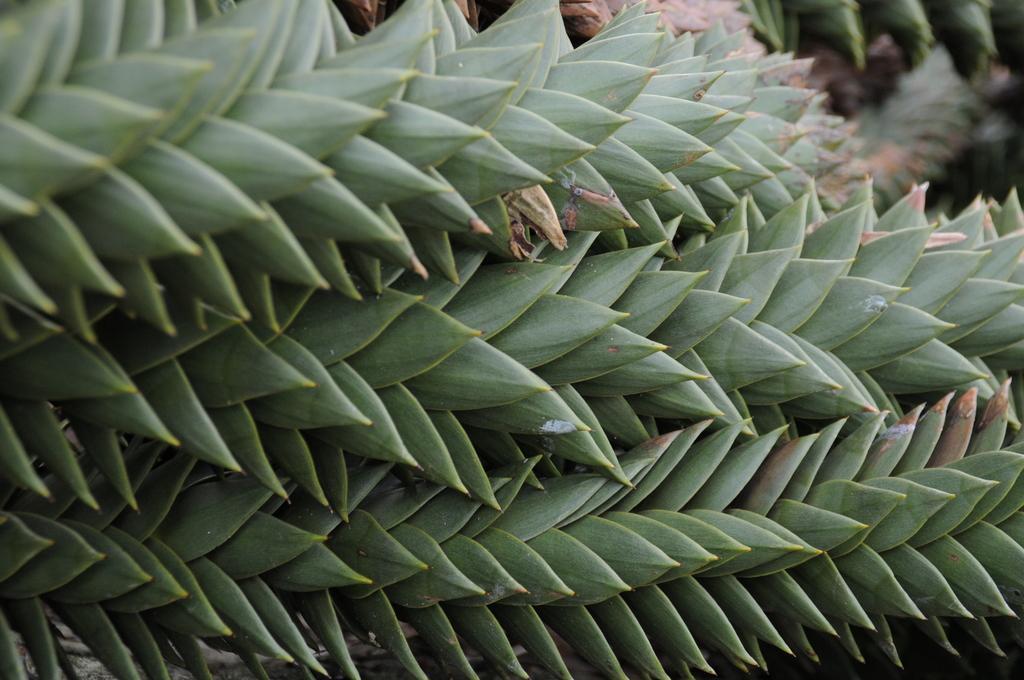Can you describe this image briefly? Here in this picture we can see plants present all over there. 